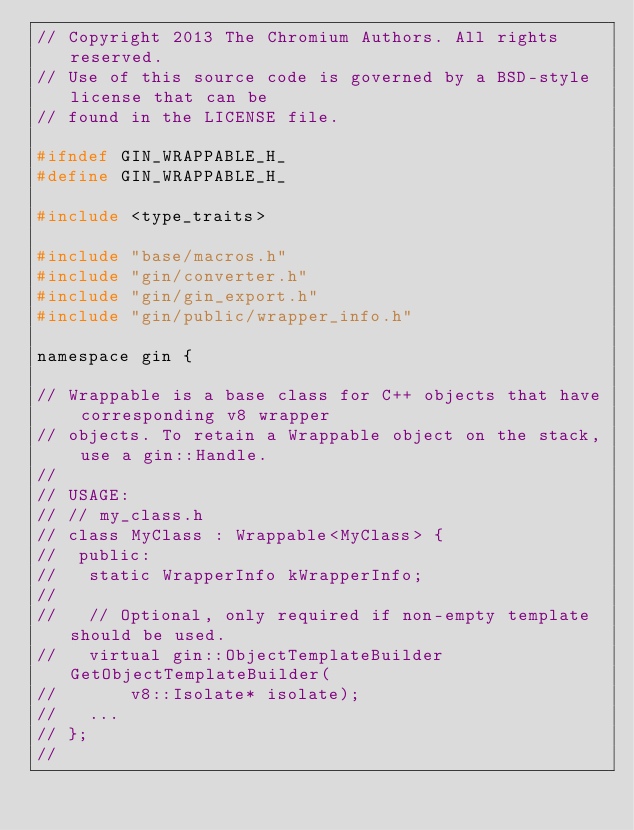<code> <loc_0><loc_0><loc_500><loc_500><_C_>// Copyright 2013 The Chromium Authors. All rights reserved.
// Use of this source code is governed by a BSD-style license that can be
// found in the LICENSE file.

#ifndef GIN_WRAPPABLE_H_
#define GIN_WRAPPABLE_H_

#include <type_traits>

#include "base/macros.h"
#include "gin/converter.h"
#include "gin/gin_export.h"
#include "gin/public/wrapper_info.h"

namespace gin {

// Wrappable is a base class for C++ objects that have corresponding v8 wrapper
// objects. To retain a Wrappable object on the stack, use a gin::Handle.
//
// USAGE:
// // my_class.h
// class MyClass : Wrappable<MyClass> {
//  public:
//   static WrapperInfo kWrapperInfo;
//
//   // Optional, only required if non-empty template should be used.
//   virtual gin::ObjectTemplateBuilder GetObjectTemplateBuilder(
//       v8::Isolate* isolate);
//   ...
// };
//</code> 